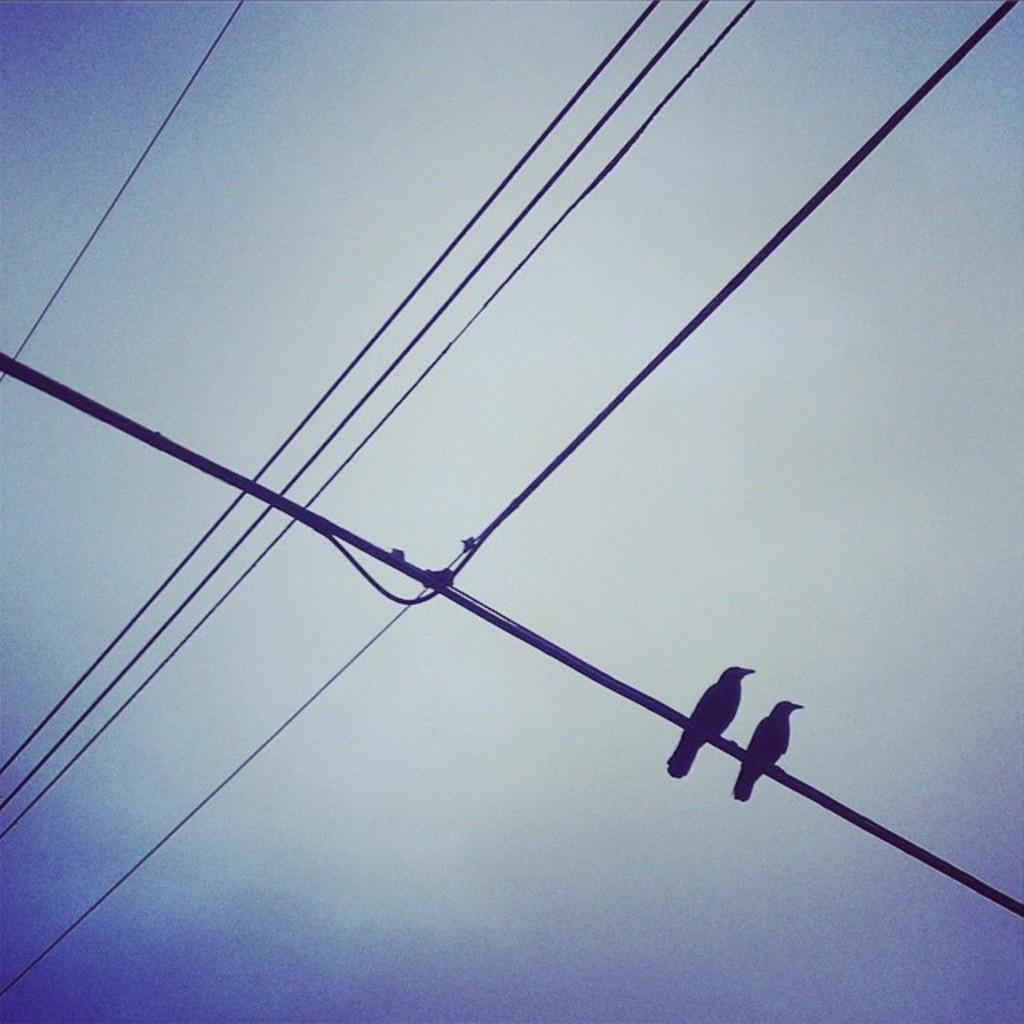What can be seen in the image that is related to electricity or communication? There are wires in the image. What animals are present on the wires? There are two birds on a wire. What can be seen in the distance in the image? The sky is visible in the background of the image. How do the birds maintain their balance on the wire while performing a jump in the image? There is no indication in the image that the birds are performing a jump or maintaining their balance on the wire. 